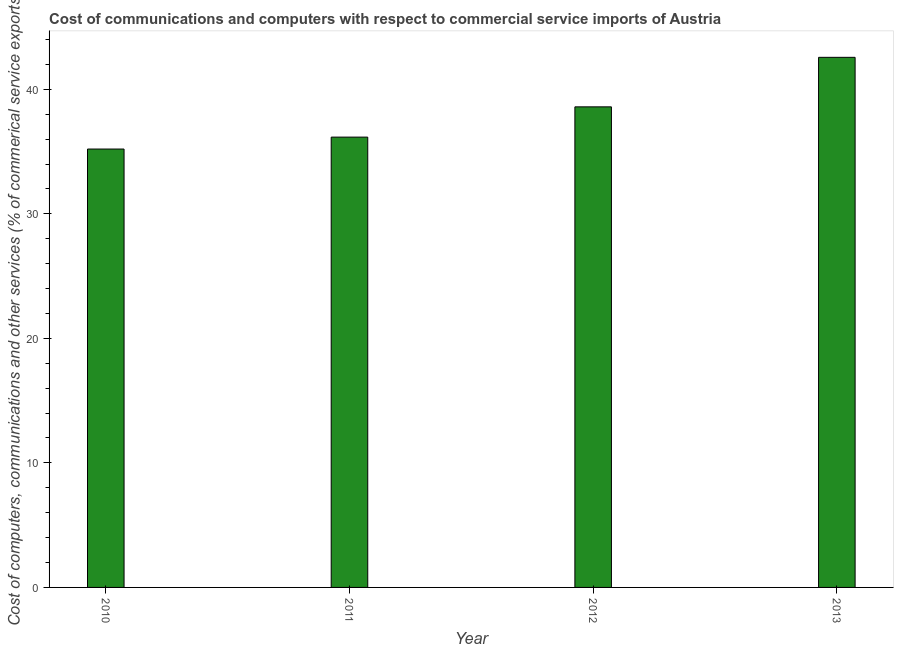Does the graph contain grids?
Offer a very short reply. No. What is the title of the graph?
Your answer should be compact. Cost of communications and computers with respect to commercial service imports of Austria. What is the label or title of the X-axis?
Offer a very short reply. Year. What is the label or title of the Y-axis?
Provide a short and direct response. Cost of computers, communications and other services (% of commerical service exports). What is the  computer and other services in 2013?
Provide a short and direct response. 42.57. Across all years, what is the maximum  computer and other services?
Keep it short and to the point. 42.57. Across all years, what is the minimum cost of communications?
Make the answer very short. 35.2. What is the sum of the cost of communications?
Keep it short and to the point. 152.53. What is the difference between the  computer and other services in 2010 and 2012?
Ensure brevity in your answer.  -3.39. What is the average cost of communications per year?
Provide a succinct answer. 38.13. What is the median cost of communications?
Provide a short and direct response. 37.38. In how many years, is the  computer and other services greater than 38 %?
Give a very brief answer. 2. What is the ratio of the cost of communications in 2011 to that in 2013?
Your response must be concise. 0.85. Is the  computer and other services in 2011 less than that in 2013?
Offer a very short reply. Yes. Is the difference between the  computer and other services in 2010 and 2012 greater than the difference between any two years?
Ensure brevity in your answer.  No. What is the difference between the highest and the second highest  computer and other services?
Give a very brief answer. 3.98. What is the difference between the highest and the lowest cost of communications?
Give a very brief answer. 7.37. How many bars are there?
Provide a succinct answer. 4. Are the values on the major ticks of Y-axis written in scientific E-notation?
Give a very brief answer. No. What is the Cost of computers, communications and other services (% of commerical service exports) of 2010?
Your response must be concise. 35.2. What is the Cost of computers, communications and other services (% of commerical service exports) in 2011?
Keep it short and to the point. 36.16. What is the Cost of computers, communications and other services (% of commerical service exports) in 2012?
Offer a very short reply. 38.59. What is the Cost of computers, communications and other services (% of commerical service exports) of 2013?
Your answer should be compact. 42.57. What is the difference between the Cost of computers, communications and other services (% of commerical service exports) in 2010 and 2011?
Your answer should be compact. -0.96. What is the difference between the Cost of computers, communications and other services (% of commerical service exports) in 2010 and 2012?
Provide a short and direct response. -3.39. What is the difference between the Cost of computers, communications and other services (% of commerical service exports) in 2010 and 2013?
Your response must be concise. -7.37. What is the difference between the Cost of computers, communications and other services (% of commerical service exports) in 2011 and 2012?
Make the answer very short. -2.43. What is the difference between the Cost of computers, communications and other services (% of commerical service exports) in 2011 and 2013?
Offer a terse response. -6.41. What is the difference between the Cost of computers, communications and other services (% of commerical service exports) in 2012 and 2013?
Your answer should be compact. -3.98. What is the ratio of the Cost of computers, communications and other services (% of commerical service exports) in 2010 to that in 2012?
Offer a terse response. 0.91. What is the ratio of the Cost of computers, communications and other services (% of commerical service exports) in 2010 to that in 2013?
Offer a very short reply. 0.83. What is the ratio of the Cost of computers, communications and other services (% of commerical service exports) in 2011 to that in 2012?
Keep it short and to the point. 0.94. What is the ratio of the Cost of computers, communications and other services (% of commerical service exports) in 2011 to that in 2013?
Provide a short and direct response. 0.85. What is the ratio of the Cost of computers, communications and other services (% of commerical service exports) in 2012 to that in 2013?
Offer a terse response. 0.91. 